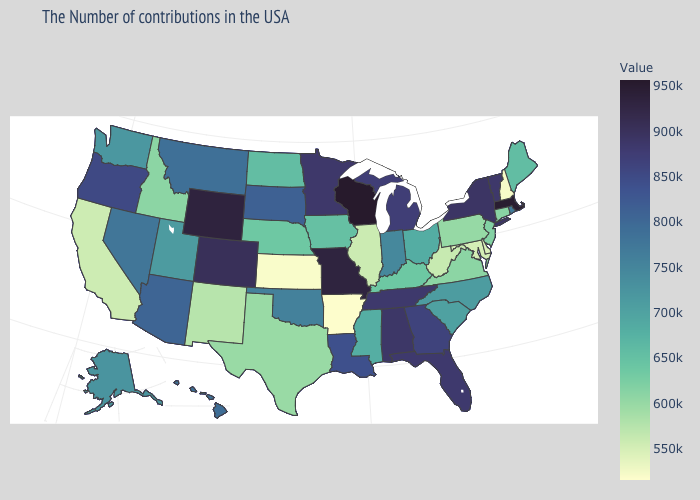Which states hav the highest value in the South?
Keep it brief. Alabama. Which states have the highest value in the USA?
Quick response, please. Wisconsin. Does Nevada have a lower value than Michigan?
Quick response, please. Yes. Among the states that border Idaho , does Wyoming have the highest value?
Write a very short answer. Yes. Among the states that border California , does Oregon have the highest value?
Be succinct. Yes. Among the states that border Idaho , which have the highest value?
Answer briefly. Wyoming. Which states have the lowest value in the South?
Answer briefly. Arkansas. 